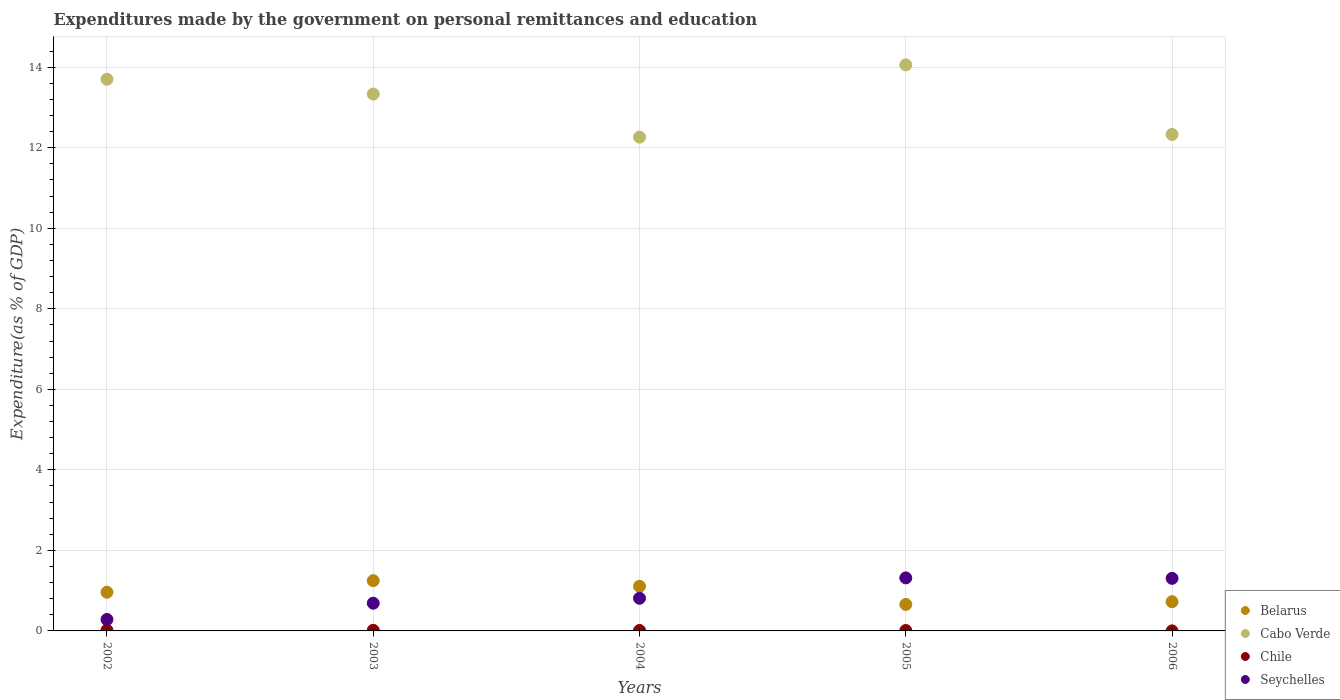How many different coloured dotlines are there?
Offer a very short reply. 4. What is the expenditures made by the government on personal remittances and education in Cabo Verde in 2003?
Ensure brevity in your answer.  13.33. Across all years, what is the maximum expenditures made by the government on personal remittances and education in Cabo Verde?
Offer a terse response. 14.06. Across all years, what is the minimum expenditures made by the government on personal remittances and education in Chile?
Give a very brief answer. 0. In which year was the expenditures made by the government on personal remittances and education in Seychelles minimum?
Make the answer very short. 2002. What is the total expenditures made by the government on personal remittances and education in Belarus in the graph?
Make the answer very short. 4.7. What is the difference between the expenditures made by the government on personal remittances and education in Cabo Verde in 2003 and that in 2005?
Offer a very short reply. -0.72. What is the difference between the expenditures made by the government on personal remittances and education in Seychelles in 2006 and the expenditures made by the government on personal remittances and education in Belarus in 2003?
Your answer should be compact. 0.06. What is the average expenditures made by the government on personal remittances and education in Belarus per year?
Keep it short and to the point. 0.94. In the year 2003, what is the difference between the expenditures made by the government on personal remittances and education in Seychelles and expenditures made by the government on personal remittances and education in Cabo Verde?
Your answer should be very brief. -12.65. In how many years, is the expenditures made by the government on personal remittances and education in Seychelles greater than 11.2 %?
Make the answer very short. 0. What is the ratio of the expenditures made by the government on personal remittances and education in Cabo Verde in 2002 to that in 2004?
Give a very brief answer. 1.12. What is the difference between the highest and the second highest expenditures made by the government on personal remittances and education in Seychelles?
Offer a terse response. 0.01. What is the difference between the highest and the lowest expenditures made by the government on personal remittances and education in Cabo Verde?
Provide a short and direct response. 1.8. In how many years, is the expenditures made by the government on personal remittances and education in Cabo Verde greater than the average expenditures made by the government on personal remittances and education in Cabo Verde taken over all years?
Provide a short and direct response. 3. Is it the case that in every year, the sum of the expenditures made by the government on personal remittances and education in Seychelles and expenditures made by the government on personal remittances and education in Chile  is greater than the expenditures made by the government on personal remittances and education in Belarus?
Your answer should be very brief. No. Is the expenditures made by the government on personal remittances and education in Seychelles strictly greater than the expenditures made by the government on personal remittances and education in Cabo Verde over the years?
Your answer should be very brief. No. How many dotlines are there?
Make the answer very short. 4. Are the values on the major ticks of Y-axis written in scientific E-notation?
Keep it short and to the point. No. Where does the legend appear in the graph?
Keep it short and to the point. Bottom right. How many legend labels are there?
Offer a terse response. 4. How are the legend labels stacked?
Offer a very short reply. Vertical. What is the title of the graph?
Ensure brevity in your answer.  Expenditures made by the government on personal remittances and education. What is the label or title of the X-axis?
Offer a terse response. Years. What is the label or title of the Y-axis?
Your answer should be very brief. Expenditure(as % of GDP). What is the Expenditure(as % of GDP) in Belarus in 2002?
Keep it short and to the point. 0.96. What is the Expenditure(as % of GDP) of Cabo Verde in 2002?
Ensure brevity in your answer.  13.7. What is the Expenditure(as % of GDP) in Chile in 2002?
Provide a short and direct response. 0.02. What is the Expenditure(as % of GDP) in Seychelles in 2002?
Give a very brief answer. 0.28. What is the Expenditure(as % of GDP) in Belarus in 2003?
Provide a short and direct response. 1.25. What is the Expenditure(as % of GDP) in Cabo Verde in 2003?
Keep it short and to the point. 13.33. What is the Expenditure(as % of GDP) of Chile in 2003?
Offer a very short reply. 0.02. What is the Expenditure(as % of GDP) in Seychelles in 2003?
Offer a terse response. 0.69. What is the Expenditure(as % of GDP) of Belarus in 2004?
Give a very brief answer. 1.11. What is the Expenditure(as % of GDP) of Cabo Verde in 2004?
Your answer should be very brief. 12.26. What is the Expenditure(as % of GDP) of Chile in 2004?
Make the answer very short. 0.01. What is the Expenditure(as % of GDP) in Seychelles in 2004?
Your answer should be very brief. 0.81. What is the Expenditure(as % of GDP) in Belarus in 2005?
Your answer should be very brief. 0.66. What is the Expenditure(as % of GDP) of Cabo Verde in 2005?
Give a very brief answer. 14.06. What is the Expenditure(as % of GDP) of Chile in 2005?
Ensure brevity in your answer.  0.01. What is the Expenditure(as % of GDP) in Seychelles in 2005?
Your answer should be very brief. 1.32. What is the Expenditure(as % of GDP) in Belarus in 2006?
Your answer should be compact. 0.73. What is the Expenditure(as % of GDP) in Cabo Verde in 2006?
Your response must be concise. 12.33. What is the Expenditure(as % of GDP) in Chile in 2006?
Your answer should be very brief. 0. What is the Expenditure(as % of GDP) in Seychelles in 2006?
Provide a succinct answer. 1.31. Across all years, what is the maximum Expenditure(as % of GDP) of Belarus?
Your answer should be compact. 1.25. Across all years, what is the maximum Expenditure(as % of GDP) of Cabo Verde?
Give a very brief answer. 14.06. Across all years, what is the maximum Expenditure(as % of GDP) in Chile?
Offer a very short reply. 0.02. Across all years, what is the maximum Expenditure(as % of GDP) in Seychelles?
Your response must be concise. 1.32. Across all years, what is the minimum Expenditure(as % of GDP) in Belarus?
Your answer should be very brief. 0.66. Across all years, what is the minimum Expenditure(as % of GDP) in Cabo Verde?
Offer a very short reply. 12.26. Across all years, what is the minimum Expenditure(as % of GDP) in Chile?
Your response must be concise. 0. Across all years, what is the minimum Expenditure(as % of GDP) of Seychelles?
Ensure brevity in your answer.  0.28. What is the total Expenditure(as % of GDP) in Belarus in the graph?
Your response must be concise. 4.7. What is the total Expenditure(as % of GDP) of Cabo Verde in the graph?
Your answer should be compact. 65.69. What is the total Expenditure(as % of GDP) in Chile in the graph?
Give a very brief answer. 0.06. What is the total Expenditure(as % of GDP) of Seychelles in the graph?
Ensure brevity in your answer.  4.41. What is the difference between the Expenditure(as % of GDP) of Belarus in 2002 and that in 2003?
Provide a short and direct response. -0.29. What is the difference between the Expenditure(as % of GDP) of Cabo Verde in 2002 and that in 2003?
Make the answer very short. 0.37. What is the difference between the Expenditure(as % of GDP) of Chile in 2002 and that in 2003?
Provide a succinct answer. 0. What is the difference between the Expenditure(as % of GDP) in Seychelles in 2002 and that in 2003?
Provide a succinct answer. -0.4. What is the difference between the Expenditure(as % of GDP) of Belarus in 2002 and that in 2004?
Your answer should be very brief. -0.15. What is the difference between the Expenditure(as % of GDP) of Cabo Verde in 2002 and that in 2004?
Give a very brief answer. 1.44. What is the difference between the Expenditure(as % of GDP) in Chile in 2002 and that in 2004?
Offer a very short reply. 0.01. What is the difference between the Expenditure(as % of GDP) in Seychelles in 2002 and that in 2004?
Give a very brief answer. -0.53. What is the difference between the Expenditure(as % of GDP) in Belarus in 2002 and that in 2005?
Give a very brief answer. 0.3. What is the difference between the Expenditure(as % of GDP) of Cabo Verde in 2002 and that in 2005?
Ensure brevity in your answer.  -0.36. What is the difference between the Expenditure(as % of GDP) in Chile in 2002 and that in 2005?
Offer a terse response. 0.01. What is the difference between the Expenditure(as % of GDP) of Seychelles in 2002 and that in 2005?
Your answer should be very brief. -1.03. What is the difference between the Expenditure(as % of GDP) of Belarus in 2002 and that in 2006?
Ensure brevity in your answer.  0.24. What is the difference between the Expenditure(as % of GDP) in Cabo Verde in 2002 and that in 2006?
Your answer should be very brief. 1.37. What is the difference between the Expenditure(as % of GDP) in Chile in 2002 and that in 2006?
Make the answer very short. 0.02. What is the difference between the Expenditure(as % of GDP) in Seychelles in 2002 and that in 2006?
Offer a terse response. -1.02. What is the difference between the Expenditure(as % of GDP) in Belarus in 2003 and that in 2004?
Provide a succinct answer. 0.14. What is the difference between the Expenditure(as % of GDP) in Cabo Verde in 2003 and that in 2004?
Keep it short and to the point. 1.07. What is the difference between the Expenditure(as % of GDP) of Chile in 2003 and that in 2004?
Provide a succinct answer. 0. What is the difference between the Expenditure(as % of GDP) of Seychelles in 2003 and that in 2004?
Keep it short and to the point. -0.12. What is the difference between the Expenditure(as % of GDP) in Belarus in 2003 and that in 2005?
Ensure brevity in your answer.  0.59. What is the difference between the Expenditure(as % of GDP) of Cabo Verde in 2003 and that in 2005?
Provide a succinct answer. -0.72. What is the difference between the Expenditure(as % of GDP) of Chile in 2003 and that in 2005?
Provide a short and direct response. 0. What is the difference between the Expenditure(as % of GDP) of Seychelles in 2003 and that in 2005?
Provide a short and direct response. -0.63. What is the difference between the Expenditure(as % of GDP) of Belarus in 2003 and that in 2006?
Ensure brevity in your answer.  0.52. What is the difference between the Expenditure(as % of GDP) in Chile in 2003 and that in 2006?
Provide a succinct answer. 0.01. What is the difference between the Expenditure(as % of GDP) of Seychelles in 2003 and that in 2006?
Provide a short and direct response. -0.62. What is the difference between the Expenditure(as % of GDP) of Belarus in 2004 and that in 2005?
Ensure brevity in your answer.  0.45. What is the difference between the Expenditure(as % of GDP) in Cabo Verde in 2004 and that in 2005?
Provide a short and direct response. -1.79. What is the difference between the Expenditure(as % of GDP) of Chile in 2004 and that in 2005?
Offer a terse response. 0. What is the difference between the Expenditure(as % of GDP) in Seychelles in 2004 and that in 2005?
Keep it short and to the point. -0.51. What is the difference between the Expenditure(as % of GDP) of Belarus in 2004 and that in 2006?
Keep it short and to the point. 0.38. What is the difference between the Expenditure(as % of GDP) of Cabo Verde in 2004 and that in 2006?
Ensure brevity in your answer.  -0.07. What is the difference between the Expenditure(as % of GDP) in Chile in 2004 and that in 2006?
Offer a very short reply. 0.01. What is the difference between the Expenditure(as % of GDP) of Seychelles in 2004 and that in 2006?
Give a very brief answer. -0.49. What is the difference between the Expenditure(as % of GDP) in Belarus in 2005 and that in 2006?
Your answer should be very brief. -0.07. What is the difference between the Expenditure(as % of GDP) in Cabo Verde in 2005 and that in 2006?
Your answer should be very brief. 1.73. What is the difference between the Expenditure(as % of GDP) in Chile in 2005 and that in 2006?
Offer a terse response. 0.01. What is the difference between the Expenditure(as % of GDP) of Seychelles in 2005 and that in 2006?
Provide a short and direct response. 0.01. What is the difference between the Expenditure(as % of GDP) in Belarus in 2002 and the Expenditure(as % of GDP) in Cabo Verde in 2003?
Keep it short and to the point. -12.37. What is the difference between the Expenditure(as % of GDP) of Belarus in 2002 and the Expenditure(as % of GDP) of Chile in 2003?
Make the answer very short. 0.95. What is the difference between the Expenditure(as % of GDP) in Belarus in 2002 and the Expenditure(as % of GDP) in Seychelles in 2003?
Make the answer very short. 0.27. What is the difference between the Expenditure(as % of GDP) of Cabo Verde in 2002 and the Expenditure(as % of GDP) of Chile in 2003?
Make the answer very short. 13.69. What is the difference between the Expenditure(as % of GDP) of Cabo Verde in 2002 and the Expenditure(as % of GDP) of Seychelles in 2003?
Your answer should be compact. 13.01. What is the difference between the Expenditure(as % of GDP) of Chile in 2002 and the Expenditure(as % of GDP) of Seychelles in 2003?
Your response must be concise. -0.67. What is the difference between the Expenditure(as % of GDP) in Belarus in 2002 and the Expenditure(as % of GDP) in Cabo Verde in 2004?
Your answer should be compact. -11.3. What is the difference between the Expenditure(as % of GDP) in Belarus in 2002 and the Expenditure(as % of GDP) in Chile in 2004?
Offer a terse response. 0.95. What is the difference between the Expenditure(as % of GDP) in Belarus in 2002 and the Expenditure(as % of GDP) in Seychelles in 2004?
Offer a very short reply. 0.15. What is the difference between the Expenditure(as % of GDP) in Cabo Verde in 2002 and the Expenditure(as % of GDP) in Chile in 2004?
Provide a short and direct response. 13.69. What is the difference between the Expenditure(as % of GDP) of Cabo Verde in 2002 and the Expenditure(as % of GDP) of Seychelles in 2004?
Your answer should be compact. 12.89. What is the difference between the Expenditure(as % of GDP) of Chile in 2002 and the Expenditure(as % of GDP) of Seychelles in 2004?
Provide a succinct answer. -0.79. What is the difference between the Expenditure(as % of GDP) of Belarus in 2002 and the Expenditure(as % of GDP) of Cabo Verde in 2005?
Your answer should be compact. -13.1. What is the difference between the Expenditure(as % of GDP) of Belarus in 2002 and the Expenditure(as % of GDP) of Chile in 2005?
Offer a very short reply. 0.95. What is the difference between the Expenditure(as % of GDP) of Belarus in 2002 and the Expenditure(as % of GDP) of Seychelles in 2005?
Provide a short and direct response. -0.36. What is the difference between the Expenditure(as % of GDP) in Cabo Verde in 2002 and the Expenditure(as % of GDP) in Chile in 2005?
Offer a terse response. 13.69. What is the difference between the Expenditure(as % of GDP) in Cabo Verde in 2002 and the Expenditure(as % of GDP) in Seychelles in 2005?
Your answer should be compact. 12.38. What is the difference between the Expenditure(as % of GDP) in Chile in 2002 and the Expenditure(as % of GDP) in Seychelles in 2005?
Your answer should be very brief. -1.3. What is the difference between the Expenditure(as % of GDP) in Belarus in 2002 and the Expenditure(as % of GDP) in Cabo Verde in 2006?
Your answer should be compact. -11.37. What is the difference between the Expenditure(as % of GDP) of Belarus in 2002 and the Expenditure(as % of GDP) of Chile in 2006?
Your answer should be compact. 0.96. What is the difference between the Expenditure(as % of GDP) of Belarus in 2002 and the Expenditure(as % of GDP) of Seychelles in 2006?
Your answer should be very brief. -0.34. What is the difference between the Expenditure(as % of GDP) in Cabo Verde in 2002 and the Expenditure(as % of GDP) in Chile in 2006?
Your response must be concise. 13.7. What is the difference between the Expenditure(as % of GDP) in Cabo Verde in 2002 and the Expenditure(as % of GDP) in Seychelles in 2006?
Your response must be concise. 12.4. What is the difference between the Expenditure(as % of GDP) of Chile in 2002 and the Expenditure(as % of GDP) of Seychelles in 2006?
Give a very brief answer. -1.29. What is the difference between the Expenditure(as % of GDP) of Belarus in 2003 and the Expenditure(as % of GDP) of Cabo Verde in 2004?
Provide a succinct answer. -11.02. What is the difference between the Expenditure(as % of GDP) of Belarus in 2003 and the Expenditure(as % of GDP) of Chile in 2004?
Your answer should be very brief. 1.24. What is the difference between the Expenditure(as % of GDP) in Belarus in 2003 and the Expenditure(as % of GDP) in Seychelles in 2004?
Offer a very short reply. 0.44. What is the difference between the Expenditure(as % of GDP) in Cabo Verde in 2003 and the Expenditure(as % of GDP) in Chile in 2004?
Your response must be concise. 13.32. What is the difference between the Expenditure(as % of GDP) in Cabo Verde in 2003 and the Expenditure(as % of GDP) in Seychelles in 2004?
Ensure brevity in your answer.  12.52. What is the difference between the Expenditure(as % of GDP) of Chile in 2003 and the Expenditure(as % of GDP) of Seychelles in 2004?
Keep it short and to the point. -0.8. What is the difference between the Expenditure(as % of GDP) of Belarus in 2003 and the Expenditure(as % of GDP) of Cabo Verde in 2005?
Provide a succinct answer. -12.81. What is the difference between the Expenditure(as % of GDP) of Belarus in 2003 and the Expenditure(as % of GDP) of Chile in 2005?
Provide a succinct answer. 1.24. What is the difference between the Expenditure(as % of GDP) in Belarus in 2003 and the Expenditure(as % of GDP) in Seychelles in 2005?
Offer a very short reply. -0.07. What is the difference between the Expenditure(as % of GDP) in Cabo Verde in 2003 and the Expenditure(as % of GDP) in Chile in 2005?
Provide a succinct answer. 13.32. What is the difference between the Expenditure(as % of GDP) of Cabo Verde in 2003 and the Expenditure(as % of GDP) of Seychelles in 2005?
Give a very brief answer. 12.02. What is the difference between the Expenditure(as % of GDP) of Chile in 2003 and the Expenditure(as % of GDP) of Seychelles in 2005?
Your answer should be very brief. -1.3. What is the difference between the Expenditure(as % of GDP) of Belarus in 2003 and the Expenditure(as % of GDP) of Cabo Verde in 2006?
Your response must be concise. -11.08. What is the difference between the Expenditure(as % of GDP) in Belarus in 2003 and the Expenditure(as % of GDP) in Chile in 2006?
Give a very brief answer. 1.25. What is the difference between the Expenditure(as % of GDP) of Belarus in 2003 and the Expenditure(as % of GDP) of Seychelles in 2006?
Ensure brevity in your answer.  -0.06. What is the difference between the Expenditure(as % of GDP) of Cabo Verde in 2003 and the Expenditure(as % of GDP) of Chile in 2006?
Your response must be concise. 13.33. What is the difference between the Expenditure(as % of GDP) of Cabo Verde in 2003 and the Expenditure(as % of GDP) of Seychelles in 2006?
Offer a very short reply. 12.03. What is the difference between the Expenditure(as % of GDP) in Chile in 2003 and the Expenditure(as % of GDP) in Seychelles in 2006?
Offer a very short reply. -1.29. What is the difference between the Expenditure(as % of GDP) of Belarus in 2004 and the Expenditure(as % of GDP) of Cabo Verde in 2005?
Offer a terse response. -12.95. What is the difference between the Expenditure(as % of GDP) in Belarus in 2004 and the Expenditure(as % of GDP) in Chile in 2005?
Give a very brief answer. 1.1. What is the difference between the Expenditure(as % of GDP) in Belarus in 2004 and the Expenditure(as % of GDP) in Seychelles in 2005?
Ensure brevity in your answer.  -0.21. What is the difference between the Expenditure(as % of GDP) in Cabo Verde in 2004 and the Expenditure(as % of GDP) in Chile in 2005?
Offer a terse response. 12.25. What is the difference between the Expenditure(as % of GDP) of Cabo Verde in 2004 and the Expenditure(as % of GDP) of Seychelles in 2005?
Offer a very short reply. 10.95. What is the difference between the Expenditure(as % of GDP) of Chile in 2004 and the Expenditure(as % of GDP) of Seychelles in 2005?
Your answer should be very brief. -1.31. What is the difference between the Expenditure(as % of GDP) in Belarus in 2004 and the Expenditure(as % of GDP) in Cabo Verde in 2006?
Offer a very short reply. -11.22. What is the difference between the Expenditure(as % of GDP) of Belarus in 2004 and the Expenditure(as % of GDP) of Chile in 2006?
Your response must be concise. 1.11. What is the difference between the Expenditure(as % of GDP) in Belarus in 2004 and the Expenditure(as % of GDP) in Seychelles in 2006?
Give a very brief answer. -0.2. What is the difference between the Expenditure(as % of GDP) of Cabo Verde in 2004 and the Expenditure(as % of GDP) of Chile in 2006?
Make the answer very short. 12.26. What is the difference between the Expenditure(as % of GDP) of Cabo Verde in 2004 and the Expenditure(as % of GDP) of Seychelles in 2006?
Your answer should be very brief. 10.96. What is the difference between the Expenditure(as % of GDP) in Chile in 2004 and the Expenditure(as % of GDP) in Seychelles in 2006?
Your answer should be compact. -1.29. What is the difference between the Expenditure(as % of GDP) in Belarus in 2005 and the Expenditure(as % of GDP) in Cabo Verde in 2006?
Your response must be concise. -11.67. What is the difference between the Expenditure(as % of GDP) of Belarus in 2005 and the Expenditure(as % of GDP) of Chile in 2006?
Offer a very short reply. 0.66. What is the difference between the Expenditure(as % of GDP) of Belarus in 2005 and the Expenditure(as % of GDP) of Seychelles in 2006?
Ensure brevity in your answer.  -0.65. What is the difference between the Expenditure(as % of GDP) of Cabo Verde in 2005 and the Expenditure(as % of GDP) of Chile in 2006?
Provide a short and direct response. 14.06. What is the difference between the Expenditure(as % of GDP) of Cabo Verde in 2005 and the Expenditure(as % of GDP) of Seychelles in 2006?
Give a very brief answer. 12.75. What is the difference between the Expenditure(as % of GDP) of Chile in 2005 and the Expenditure(as % of GDP) of Seychelles in 2006?
Keep it short and to the point. -1.3. What is the average Expenditure(as % of GDP) of Belarus per year?
Your answer should be compact. 0.94. What is the average Expenditure(as % of GDP) of Cabo Verde per year?
Keep it short and to the point. 13.14. What is the average Expenditure(as % of GDP) in Chile per year?
Keep it short and to the point. 0.01. What is the average Expenditure(as % of GDP) in Seychelles per year?
Offer a terse response. 0.88. In the year 2002, what is the difference between the Expenditure(as % of GDP) in Belarus and Expenditure(as % of GDP) in Cabo Verde?
Offer a very short reply. -12.74. In the year 2002, what is the difference between the Expenditure(as % of GDP) of Belarus and Expenditure(as % of GDP) of Chile?
Ensure brevity in your answer.  0.94. In the year 2002, what is the difference between the Expenditure(as % of GDP) in Belarus and Expenditure(as % of GDP) in Seychelles?
Make the answer very short. 0.68. In the year 2002, what is the difference between the Expenditure(as % of GDP) in Cabo Verde and Expenditure(as % of GDP) in Chile?
Make the answer very short. 13.68. In the year 2002, what is the difference between the Expenditure(as % of GDP) in Cabo Verde and Expenditure(as % of GDP) in Seychelles?
Your response must be concise. 13.42. In the year 2002, what is the difference between the Expenditure(as % of GDP) in Chile and Expenditure(as % of GDP) in Seychelles?
Your response must be concise. -0.27. In the year 2003, what is the difference between the Expenditure(as % of GDP) in Belarus and Expenditure(as % of GDP) in Cabo Verde?
Your answer should be compact. -12.09. In the year 2003, what is the difference between the Expenditure(as % of GDP) in Belarus and Expenditure(as % of GDP) in Chile?
Offer a terse response. 1.23. In the year 2003, what is the difference between the Expenditure(as % of GDP) of Belarus and Expenditure(as % of GDP) of Seychelles?
Your response must be concise. 0.56. In the year 2003, what is the difference between the Expenditure(as % of GDP) of Cabo Verde and Expenditure(as % of GDP) of Chile?
Offer a terse response. 13.32. In the year 2003, what is the difference between the Expenditure(as % of GDP) of Cabo Verde and Expenditure(as % of GDP) of Seychelles?
Your answer should be compact. 12.65. In the year 2003, what is the difference between the Expenditure(as % of GDP) of Chile and Expenditure(as % of GDP) of Seychelles?
Provide a short and direct response. -0.67. In the year 2004, what is the difference between the Expenditure(as % of GDP) of Belarus and Expenditure(as % of GDP) of Cabo Verde?
Make the answer very short. -11.15. In the year 2004, what is the difference between the Expenditure(as % of GDP) of Belarus and Expenditure(as % of GDP) of Chile?
Your response must be concise. 1.1. In the year 2004, what is the difference between the Expenditure(as % of GDP) in Belarus and Expenditure(as % of GDP) in Seychelles?
Your answer should be very brief. 0.3. In the year 2004, what is the difference between the Expenditure(as % of GDP) of Cabo Verde and Expenditure(as % of GDP) of Chile?
Your response must be concise. 12.25. In the year 2004, what is the difference between the Expenditure(as % of GDP) of Cabo Verde and Expenditure(as % of GDP) of Seychelles?
Provide a succinct answer. 11.45. In the year 2004, what is the difference between the Expenditure(as % of GDP) in Chile and Expenditure(as % of GDP) in Seychelles?
Provide a succinct answer. -0.8. In the year 2005, what is the difference between the Expenditure(as % of GDP) in Belarus and Expenditure(as % of GDP) in Cabo Verde?
Make the answer very short. -13.4. In the year 2005, what is the difference between the Expenditure(as % of GDP) in Belarus and Expenditure(as % of GDP) in Chile?
Your response must be concise. 0.65. In the year 2005, what is the difference between the Expenditure(as % of GDP) of Belarus and Expenditure(as % of GDP) of Seychelles?
Offer a terse response. -0.66. In the year 2005, what is the difference between the Expenditure(as % of GDP) in Cabo Verde and Expenditure(as % of GDP) in Chile?
Your answer should be compact. 14.05. In the year 2005, what is the difference between the Expenditure(as % of GDP) of Cabo Verde and Expenditure(as % of GDP) of Seychelles?
Your response must be concise. 12.74. In the year 2005, what is the difference between the Expenditure(as % of GDP) in Chile and Expenditure(as % of GDP) in Seychelles?
Give a very brief answer. -1.31. In the year 2006, what is the difference between the Expenditure(as % of GDP) of Belarus and Expenditure(as % of GDP) of Cabo Verde?
Make the answer very short. -11.61. In the year 2006, what is the difference between the Expenditure(as % of GDP) of Belarus and Expenditure(as % of GDP) of Chile?
Offer a terse response. 0.72. In the year 2006, what is the difference between the Expenditure(as % of GDP) in Belarus and Expenditure(as % of GDP) in Seychelles?
Your answer should be compact. -0.58. In the year 2006, what is the difference between the Expenditure(as % of GDP) in Cabo Verde and Expenditure(as % of GDP) in Chile?
Provide a succinct answer. 12.33. In the year 2006, what is the difference between the Expenditure(as % of GDP) of Cabo Verde and Expenditure(as % of GDP) of Seychelles?
Provide a short and direct response. 11.03. In the year 2006, what is the difference between the Expenditure(as % of GDP) of Chile and Expenditure(as % of GDP) of Seychelles?
Your answer should be compact. -1.3. What is the ratio of the Expenditure(as % of GDP) of Belarus in 2002 to that in 2003?
Ensure brevity in your answer.  0.77. What is the ratio of the Expenditure(as % of GDP) in Cabo Verde in 2002 to that in 2003?
Make the answer very short. 1.03. What is the ratio of the Expenditure(as % of GDP) in Chile in 2002 to that in 2003?
Offer a very short reply. 1.15. What is the ratio of the Expenditure(as % of GDP) in Seychelles in 2002 to that in 2003?
Offer a very short reply. 0.41. What is the ratio of the Expenditure(as % of GDP) in Belarus in 2002 to that in 2004?
Offer a terse response. 0.87. What is the ratio of the Expenditure(as % of GDP) of Cabo Verde in 2002 to that in 2004?
Provide a succinct answer. 1.12. What is the ratio of the Expenditure(as % of GDP) of Chile in 2002 to that in 2004?
Offer a very short reply. 1.52. What is the ratio of the Expenditure(as % of GDP) in Seychelles in 2002 to that in 2004?
Provide a succinct answer. 0.35. What is the ratio of the Expenditure(as % of GDP) in Belarus in 2002 to that in 2005?
Your answer should be very brief. 1.46. What is the ratio of the Expenditure(as % of GDP) in Cabo Verde in 2002 to that in 2005?
Keep it short and to the point. 0.97. What is the ratio of the Expenditure(as % of GDP) of Chile in 2002 to that in 2005?
Your answer should be very brief. 1.67. What is the ratio of the Expenditure(as % of GDP) of Seychelles in 2002 to that in 2005?
Give a very brief answer. 0.22. What is the ratio of the Expenditure(as % of GDP) in Belarus in 2002 to that in 2006?
Offer a terse response. 1.32. What is the ratio of the Expenditure(as % of GDP) of Chile in 2002 to that in 2006?
Your response must be concise. 10.81. What is the ratio of the Expenditure(as % of GDP) in Seychelles in 2002 to that in 2006?
Offer a terse response. 0.22. What is the ratio of the Expenditure(as % of GDP) of Belarus in 2003 to that in 2004?
Provide a short and direct response. 1.12. What is the ratio of the Expenditure(as % of GDP) in Cabo Verde in 2003 to that in 2004?
Ensure brevity in your answer.  1.09. What is the ratio of the Expenditure(as % of GDP) of Chile in 2003 to that in 2004?
Offer a terse response. 1.32. What is the ratio of the Expenditure(as % of GDP) of Seychelles in 2003 to that in 2004?
Give a very brief answer. 0.85. What is the ratio of the Expenditure(as % of GDP) in Belarus in 2003 to that in 2005?
Your response must be concise. 1.9. What is the ratio of the Expenditure(as % of GDP) of Cabo Verde in 2003 to that in 2005?
Your response must be concise. 0.95. What is the ratio of the Expenditure(as % of GDP) in Chile in 2003 to that in 2005?
Give a very brief answer. 1.45. What is the ratio of the Expenditure(as % of GDP) of Seychelles in 2003 to that in 2005?
Provide a succinct answer. 0.52. What is the ratio of the Expenditure(as % of GDP) of Belarus in 2003 to that in 2006?
Ensure brevity in your answer.  1.72. What is the ratio of the Expenditure(as % of GDP) in Cabo Verde in 2003 to that in 2006?
Your response must be concise. 1.08. What is the ratio of the Expenditure(as % of GDP) of Chile in 2003 to that in 2006?
Your answer should be compact. 9.38. What is the ratio of the Expenditure(as % of GDP) in Seychelles in 2003 to that in 2006?
Your answer should be compact. 0.53. What is the ratio of the Expenditure(as % of GDP) of Belarus in 2004 to that in 2005?
Keep it short and to the point. 1.69. What is the ratio of the Expenditure(as % of GDP) of Cabo Verde in 2004 to that in 2005?
Provide a short and direct response. 0.87. What is the ratio of the Expenditure(as % of GDP) of Chile in 2004 to that in 2005?
Ensure brevity in your answer.  1.1. What is the ratio of the Expenditure(as % of GDP) in Seychelles in 2004 to that in 2005?
Your answer should be very brief. 0.62. What is the ratio of the Expenditure(as % of GDP) in Belarus in 2004 to that in 2006?
Make the answer very short. 1.53. What is the ratio of the Expenditure(as % of GDP) of Chile in 2004 to that in 2006?
Provide a succinct answer. 7.13. What is the ratio of the Expenditure(as % of GDP) of Seychelles in 2004 to that in 2006?
Your answer should be very brief. 0.62. What is the ratio of the Expenditure(as % of GDP) in Belarus in 2005 to that in 2006?
Make the answer very short. 0.91. What is the ratio of the Expenditure(as % of GDP) in Cabo Verde in 2005 to that in 2006?
Ensure brevity in your answer.  1.14. What is the ratio of the Expenditure(as % of GDP) in Chile in 2005 to that in 2006?
Your answer should be compact. 6.47. What is the ratio of the Expenditure(as % of GDP) in Seychelles in 2005 to that in 2006?
Give a very brief answer. 1.01. What is the difference between the highest and the second highest Expenditure(as % of GDP) in Belarus?
Provide a succinct answer. 0.14. What is the difference between the highest and the second highest Expenditure(as % of GDP) in Cabo Verde?
Ensure brevity in your answer.  0.36. What is the difference between the highest and the second highest Expenditure(as % of GDP) of Chile?
Ensure brevity in your answer.  0. What is the difference between the highest and the second highest Expenditure(as % of GDP) of Seychelles?
Provide a succinct answer. 0.01. What is the difference between the highest and the lowest Expenditure(as % of GDP) in Belarus?
Give a very brief answer. 0.59. What is the difference between the highest and the lowest Expenditure(as % of GDP) of Cabo Verde?
Offer a very short reply. 1.79. What is the difference between the highest and the lowest Expenditure(as % of GDP) in Chile?
Give a very brief answer. 0.02. What is the difference between the highest and the lowest Expenditure(as % of GDP) in Seychelles?
Give a very brief answer. 1.03. 